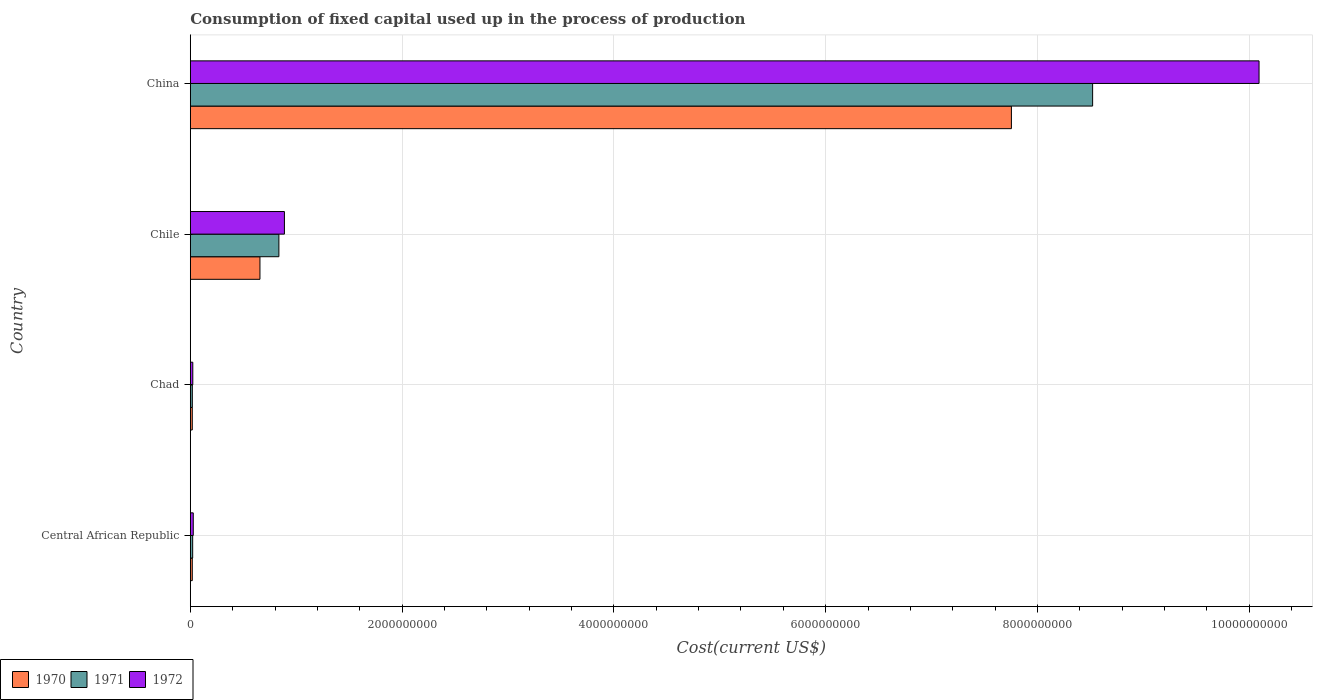How many different coloured bars are there?
Keep it short and to the point. 3. How many groups of bars are there?
Keep it short and to the point. 4. How many bars are there on the 2nd tick from the top?
Your answer should be very brief. 3. What is the label of the 3rd group of bars from the top?
Offer a terse response. Chad. What is the amount consumed in the process of production in 1970 in China?
Your response must be concise. 7.75e+09. Across all countries, what is the maximum amount consumed in the process of production in 1971?
Your answer should be very brief. 8.52e+09. Across all countries, what is the minimum amount consumed in the process of production in 1970?
Give a very brief answer. 1.87e+07. In which country was the amount consumed in the process of production in 1972 maximum?
Offer a terse response. China. In which country was the amount consumed in the process of production in 1970 minimum?
Your answer should be compact. Chad. What is the total amount consumed in the process of production in 1972 in the graph?
Make the answer very short. 1.10e+1. What is the difference between the amount consumed in the process of production in 1972 in Central African Republic and that in China?
Ensure brevity in your answer.  -1.01e+1. What is the difference between the amount consumed in the process of production in 1971 in Central African Republic and the amount consumed in the process of production in 1970 in China?
Keep it short and to the point. -7.73e+09. What is the average amount consumed in the process of production in 1970 per country?
Your response must be concise. 2.11e+09. What is the difference between the amount consumed in the process of production in 1972 and amount consumed in the process of production in 1971 in Chad?
Your answer should be very brief. 4.50e+06. What is the ratio of the amount consumed in the process of production in 1970 in Central African Republic to that in Chile?
Provide a short and direct response. 0.03. Is the amount consumed in the process of production in 1971 in Chile less than that in China?
Offer a very short reply. Yes. What is the difference between the highest and the second highest amount consumed in the process of production in 1971?
Provide a succinct answer. 7.68e+09. What is the difference between the highest and the lowest amount consumed in the process of production in 1970?
Offer a terse response. 7.74e+09. In how many countries, is the amount consumed in the process of production in 1972 greater than the average amount consumed in the process of production in 1972 taken over all countries?
Make the answer very short. 1. Is the sum of the amount consumed in the process of production in 1971 in Central African Republic and Chad greater than the maximum amount consumed in the process of production in 1972 across all countries?
Keep it short and to the point. No. Is it the case that in every country, the sum of the amount consumed in the process of production in 1972 and amount consumed in the process of production in 1971 is greater than the amount consumed in the process of production in 1970?
Your response must be concise. Yes. How many bars are there?
Provide a short and direct response. 12. Are all the bars in the graph horizontal?
Your answer should be very brief. Yes. How many countries are there in the graph?
Give a very brief answer. 4. What is the difference between two consecutive major ticks on the X-axis?
Offer a very short reply. 2.00e+09. Does the graph contain grids?
Your answer should be very brief. Yes. Where does the legend appear in the graph?
Keep it short and to the point. Bottom left. How many legend labels are there?
Make the answer very short. 3. How are the legend labels stacked?
Provide a succinct answer. Horizontal. What is the title of the graph?
Provide a succinct answer. Consumption of fixed capital used up in the process of production. What is the label or title of the X-axis?
Offer a terse response. Cost(current US$). What is the label or title of the Y-axis?
Ensure brevity in your answer.  Country. What is the Cost(current US$) in 1970 in Central African Republic?
Your answer should be compact. 1.88e+07. What is the Cost(current US$) in 1971 in Central African Republic?
Offer a very short reply. 2.25e+07. What is the Cost(current US$) in 1972 in Central African Republic?
Offer a very short reply. 2.81e+07. What is the Cost(current US$) in 1970 in Chad?
Your response must be concise. 1.87e+07. What is the Cost(current US$) in 1971 in Chad?
Provide a short and direct response. 1.92e+07. What is the Cost(current US$) of 1972 in Chad?
Offer a terse response. 2.37e+07. What is the Cost(current US$) in 1970 in Chile?
Keep it short and to the point. 6.58e+08. What is the Cost(current US$) in 1971 in Chile?
Offer a terse response. 8.37e+08. What is the Cost(current US$) of 1972 in Chile?
Provide a short and direct response. 8.89e+08. What is the Cost(current US$) in 1970 in China?
Your response must be concise. 7.75e+09. What is the Cost(current US$) of 1971 in China?
Give a very brief answer. 8.52e+09. What is the Cost(current US$) in 1972 in China?
Your answer should be compact. 1.01e+1. Across all countries, what is the maximum Cost(current US$) in 1970?
Provide a succinct answer. 7.75e+09. Across all countries, what is the maximum Cost(current US$) of 1971?
Give a very brief answer. 8.52e+09. Across all countries, what is the maximum Cost(current US$) in 1972?
Keep it short and to the point. 1.01e+1. Across all countries, what is the minimum Cost(current US$) of 1970?
Provide a succinct answer. 1.87e+07. Across all countries, what is the minimum Cost(current US$) in 1971?
Ensure brevity in your answer.  1.92e+07. Across all countries, what is the minimum Cost(current US$) of 1972?
Ensure brevity in your answer.  2.37e+07. What is the total Cost(current US$) in 1970 in the graph?
Give a very brief answer. 8.45e+09. What is the total Cost(current US$) in 1971 in the graph?
Your response must be concise. 9.40e+09. What is the total Cost(current US$) in 1972 in the graph?
Provide a short and direct response. 1.10e+1. What is the difference between the Cost(current US$) in 1970 in Central African Republic and that in Chad?
Make the answer very short. 1.44e+05. What is the difference between the Cost(current US$) of 1971 in Central African Republic and that in Chad?
Offer a very short reply. 3.32e+06. What is the difference between the Cost(current US$) in 1972 in Central African Republic and that in Chad?
Offer a very short reply. 4.39e+06. What is the difference between the Cost(current US$) in 1970 in Central African Republic and that in Chile?
Ensure brevity in your answer.  -6.39e+08. What is the difference between the Cost(current US$) of 1971 in Central African Republic and that in Chile?
Offer a terse response. -8.14e+08. What is the difference between the Cost(current US$) of 1972 in Central African Republic and that in Chile?
Offer a terse response. -8.61e+08. What is the difference between the Cost(current US$) in 1970 in Central African Republic and that in China?
Make the answer very short. -7.74e+09. What is the difference between the Cost(current US$) of 1971 in Central African Republic and that in China?
Your response must be concise. -8.50e+09. What is the difference between the Cost(current US$) of 1972 in Central African Republic and that in China?
Provide a succinct answer. -1.01e+1. What is the difference between the Cost(current US$) in 1970 in Chad and that in Chile?
Ensure brevity in your answer.  -6.39e+08. What is the difference between the Cost(current US$) in 1971 in Chad and that in Chile?
Your response must be concise. -8.17e+08. What is the difference between the Cost(current US$) in 1972 in Chad and that in Chile?
Provide a short and direct response. -8.65e+08. What is the difference between the Cost(current US$) in 1970 in Chad and that in China?
Ensure brevity in your answer.  -7.74e+09. What is the difference between the Cost(current US$) of 1971 in Chad and that in China?
Make the answer very short. -8.50e+09. What is the difference between the Cost(current US$) of 1972 in Chad and that in China?
Offer a very short reply. -1.01e+1. What is the difference between the Cost(current US$) in 1970 in Chile and that in China?
Offer a very short reply. -7.10e+09. What is the difference between the Cost(current US$) in 1971 in Chile and that in China?
Keep it short and to the point. -7.68e+09. What is the difference between the Cost(current US$) of 1972 in Chile and that in China?
Give a very brief answer. -9.20e+09. What is the difference between the Cost(current US$) of 1970 in Central African Republic and the Cost(current US$) of 1971 in Chad?
Provide a succinct answer. -3.35e+05. What is the difference between the Cost(current US$) in 1970 in Central African Republic and the Cost(current US$) in 1972 in Chad?
Provide a short and direct response. -4.84e+06. What is the difference between the Cost(current US$) of 1971 in Central African Republic and the Cost(current US$) of 1972 in Chad?
Provide a short and direct response. -1.18e+06. What is the difference between the Cost(current US$) of 1970 in Central African Republic and the Cost(current US$) of 1971 in Chile?
Give a very brief answer. -8.18e+08. What is the difference between the Cost(current US$) in 1970 in Central African Republic and the Cost(current US$) in 1972 in Chile?
Provide a short and direct response. -8.70e+08. What is the difference between the Cost(current US$) in 1971 in Central African Republic and the Cost(current US$) in 1972 in Chile?
Offer a terse response. -8.66e+08. What is the difference between the Cost(current US$) of 1970 in Central African Republic and the Cost(current US$) of 1971 in China?
Your response must be concise. -8.50e+09. What is the difference between the Cost(current US$) in 1970 in Central African Republic and the Cost(current US$) in 1972 in China?
Your answer should be compact. -1.01e+1. What is the difference between the Cost(current US$) of 1971 in Central African Republic and the Cost(current US$) of 1972 in China?
Make the answer very short. -1.01e+1. What is the difference between the Cost(current US$) of 1970 in Chad and the Cost(current US$) of 1971 in Chile?
Provide a succinct answer. -8.18e+08. What is the difference between the Cost(current US$) in 1970 in Chad and the Cost(current US$) in 1972 in Chile?
Your answer should be compact. -8.70e+08. What is the difference between the Cost(current US$) in 1971 in Chad and the Cost(current US$) in 1972 in Chile?
Your answer should be very brief. -8.70e+08. What is the difference between the Cost(current US$) in 1970 in Chad and the Cost(current US$) in 1971 in China?
Keep it short and to the point. -8.50e+09. What is the difference between the Cost(current US$) in 1970 in Chad and the Cost(current US$) in 1972 in China?
Offer a terse response. -1.01e+1. What is the difference between the Cost(current US$) in 1971 in Chad and the Cost(current US$) in 1972 in China?
Your response must be concise. -1.01e+1. What is the difference between the Cost(current US$) in 1970 in Chile and the Cost(current US$) in 1971 in China?
Ensure brevity in your answer.  -7.86e+09. What is the difference between the Cost(current US$) in 1970 in Chile and the Cost(current US$) in 1972 in China?
Make the answer very short. -9.44e+09. What is the difference between the Cost(current US$) of 1971 in Chile and the Cost(current US$) of 1972 in China?
Your answer should be compact. -9.26e+09. What is the average Cost(current US$) of 1970 per country?
Give a very brief answer. 2.11e+09. What is the average Cost(current US$) in 1971 per country?
Offer a terse response. 2.35e+09. What is the average Cost(current US$) of 1972 per country?
Provide a succinct answer. 2.76e+09. What is the difference between the Cost(current US$) in 1970 and Cost(current US$) in 1971 in Central African Republic?
Keep it short and to the point. -3.66e+06. What is the difference between the Cost(current US$) of 1970 and Cost(current US$) of 1972 in Central African Republic?
Your response must be concise. -9.23e+06. What is the difference between the Cost(current US$) in 1971 and Cost(current US$) in 1972 in Central African Republic?
Provide a short and direct response. -5.57e+06. What is the difference between the Cost(current US$) of 1970 and Cost(current US$) of 1971 in Chad?
Ensure brevity in your answer.  -4.79e+05. What is the difference between the Cost(current US$) of 1970 and Cost(current US$) of 1972 in Chad?
Give a very brief answer. -4.98e+06. What is the difference between the Cost(current US$) in 1971 and Cost(current US$) in 1972 in Chad?
Provide a succinct answer. -4.50e+06. What is the difference between the Cost(current US$) in 1970 and Cost(current US$) in 1971 in Chile?
Provide a succinct answer. -1.79e+08. What is the difference between the Cost(current US$) in 1970 and Cost(current US$) in 1972 in Chile?
Your answer should be compact. -2.31e+08. What is the difference between the Cost(current US$) in 1971 and Cost(current US$) in 1972 in Chile?
Ensure brevity in your answer.  -5.24e+07. What is the difference between the Cost(current US$) in 1970 and Cost(current US$) in 1971 in China?
Your answer should be very brief. -7.67e+08. What is the difference between the Cost(current US$) in 1970 and Cost(current US$) in 1972 in China?
Keep it short and to the point. -2.34e+09. What is the difference between the Cost(current US$) of 1971 and Cost(current US$) of 1972 in China?
Provide a succinct answer. -1.57e+09. What is the ratio of the Cost(current US$) in 1970 in Central African Republic to that in Chad?
Provide a succinct answer. 1.01. What is the ratio of the Cost(current US$) of 1971 in Central African Republic to that in Chad?
Your response must be concise. 1.17. What is the ratio of the Cost(current US$) in 1972 in Central African Republic to that in Chad?
Your response must be concise. 1.19. What is the ratio of the Cost(current US$) in 1970 in Central African Republic to that in Chile?
Offer a very short reply. 0.03. What is the ratio of the Cost(current US$) of 1971 in Central African Republic to that in Chile?
Provide a short and direct response. 0.03. What is the ratio of the Cost(current US$) of 1972 in Central African Republic to that in Chile?
Offer a very short reply. 0.03. What is the ratio of the Cost(current US$) of 1970 in Central African Republic to that in China?
Your answer should be very brief. 0. What is the ratio of the Cost(current US$) in 1971 in Central African Republic to that in China?
Your response must be concise. 0. What is the ratio of the Cost(current US$) in 1972 in Central African Republic to that in China?
Ensure brevity in your answer.  0. What is the ratio of the Cost(current US$) in 1970 in Chad to that in Chile?
Keep it short and to the point. 0.03. What is the ratio of the Cost(current US$) of 1971 in Chad to that in Chile?
Provide a short and direct response. 0.02. What is the ratio of the Cost(current US$) of 1972 in Chad to that in Chile?
Offer a very short reply. 0.03. What is the ratio of the Cost(current US$) of 1970 in Chad to that in China?
Your answer should be compact. 0. What is the ratio of the Cost(current US$) in 1971 in Chad to that in China?
Your response must be concise. 0. What is the ratio of the Cost(current US$) of 1972 in Chad to that in China?
Provide a short and direct response. 0. What is the ratio of the Cost(current US$) of 1970 in Chile to that in China?
Your answer should be very brief. 0.08. What is the ratio of the Cost(current US$) of 1971 in Chile to that in China?
Your answer should be very brief. 0.1. What is the ratio of the Cost(current US$) in 1972 in Chile to that in China?
Your response must be concise. 0.09. What is the difference between the highest and the second highest Cost(current US$) of 1970?
Offer a terse response. 7.10e+09. What is the difference between the highest and the second highest Cost(current US$) of 1971?
Offer a very short reply. 7.68e+09. What is the difference between the highest and the second highest Cost(current US$) of 1972?
Offer a terse response. 9.20e+09. What is the difference between the highest and the lowest Cost(current US$) of 1970?
Your answer should be very brief. 7.74e+09. What is the difference between the highest and the lowest Cost(current US$) in 1971?
Provide a short and direct response. 8.50e+09. What is the difference between the highest and the lowest Cost(current US$) of 1972?
Provide a short and direct response. 1.01e+1. 